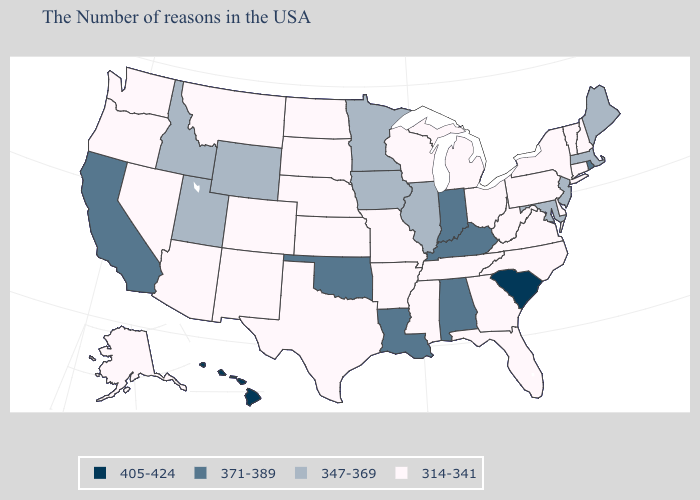Name the states that have a value in the range 371-389?
Answer briefly. Rhode Island, Kentucky, Indiana, Alabama, Louisiana, Oklahoma, California. Name the states that have a value in the range 371-389?
Write a very short answer. Rhode Island, Kentucky, Indiana, Alabama, Louisiana, Oklahoma, California. Among the states that border Maryland , which have the lowest value?
Concise answer only. Delaware, Pennsylvania, Virginia, West Virginia. Among the states that border Nevada , which have the highest value?
Write a very short answer. California. What is the value of Michigan?
Keep it brief. 314-341. Does Connecticut have a higher value than Maryland?
Answer briefly. No. Name the states that have a value in the range 371-389?
Write a very short answer. Rhode Island, Kentucky, Indiana, Alabama, Louisiana, Oklahoma, California. What is the value of Indiana?
Be succinct. 371-389. Which states hav the highest value in the South?
Concise answer only. South Carolina. How many symbols are there in the legend?
Write a very short answer. 4. What is the value of Minnesota?
Concise answer only. 347-369. Name the states that have a value in the range 347-369?
Answer briefly. Maine, Massachusetts, New Jersey, Maryland, Illinois, Minnesota, Iowa, Wyoming, Utah, Idaho. Does Pennsylvania have the same value as Wyoming?
Short answer required. No. Which states have the lowest value in the USA?
Short answer required. New Hampshire, Vermont, Connecticut, New York, Delaware, Pennsylvania, Virginia, North Carolina, West Virginia, Ohio, Florida, Georgia, Michigan, Tennessee, Wisconsin, Mississippi, Missouri, Arkansas, Kansas, Nebraska, Texas, South Dakota, North Dakota, Colorado, New Mexico, Montana, Arizona, Nevada, Washington, Oregon, Alaska. Does Vermont have the highest value in the USA?
Concise answer only. No. 